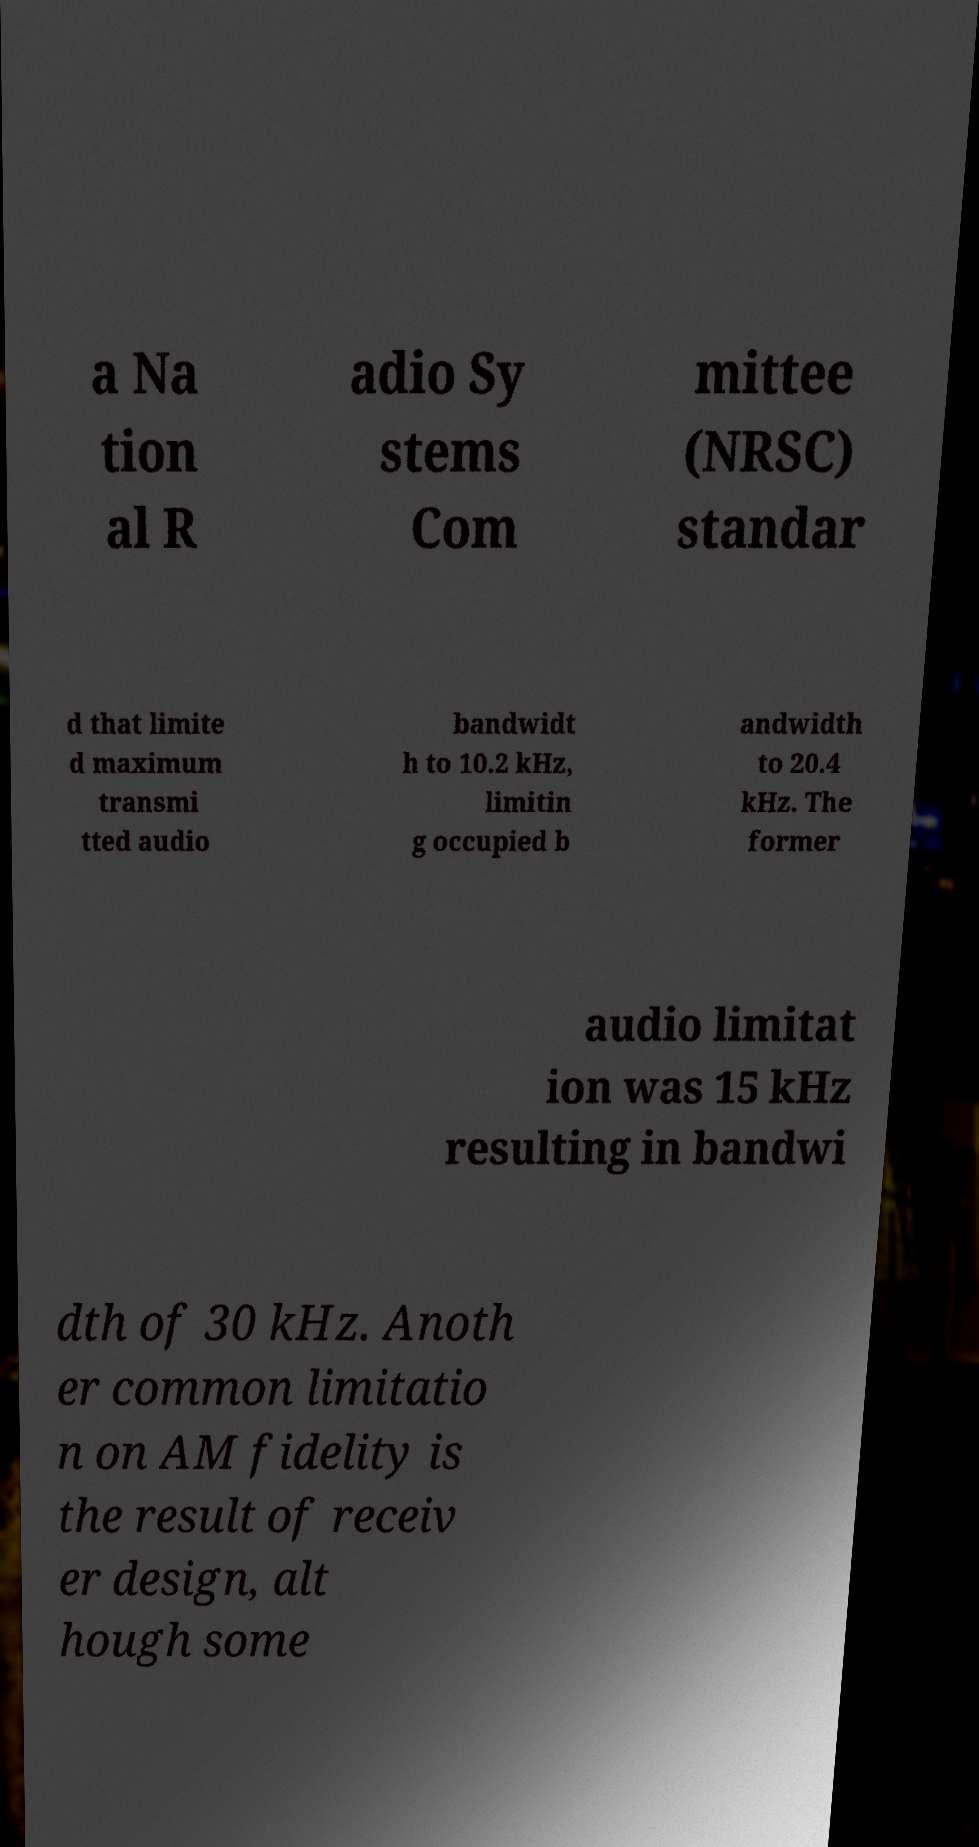Can you accurately transcribe the text from the provided image for me? a Na tion al R adio Sy stems Com mittee (NRSC) standar d that limite d maximum transmi tted audio bandwidt h to 10.2 kHz, limitin g occupied b andwidth to 20.4 kHz. The former audio limitat ion was 15 kHz resulting in bandwi dth of 30 kHz. Anoth er common limitatio n on AM fidelity is the result of receiv er design, alt hough some 